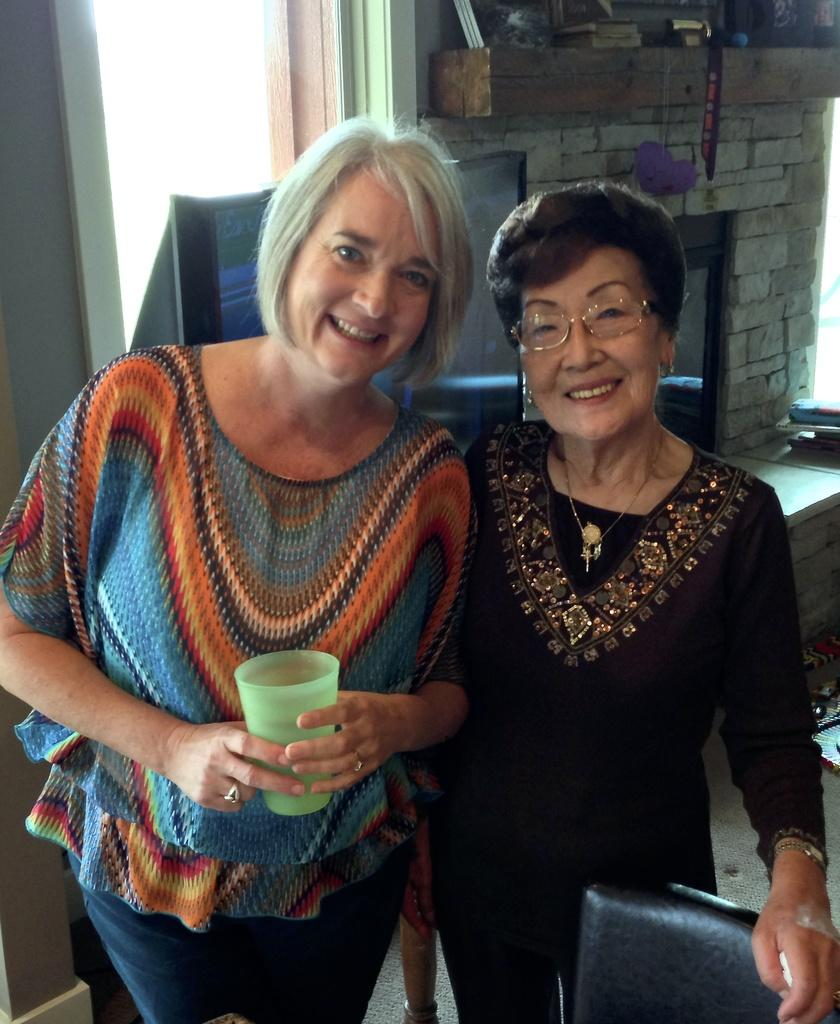How many people are present in the image? There are two people in the image. What can be observed about the clothing of the people in the image? The people are wearing different color dresses. What is one person holding in the image? One person is holding a glass. What can be seen in the background of the image? There is a screen and other objects visible in the background. Is there any indication of an outdoor setting in the image? No, there is no outdoor setting in the image. There is a window in the background, but it does not necessarily indicate an outdoor view. What type of flag can be seen in the image? There is no flag present in the image. What type of hall is visible in the background of the image? There is no hall visible in the image. 